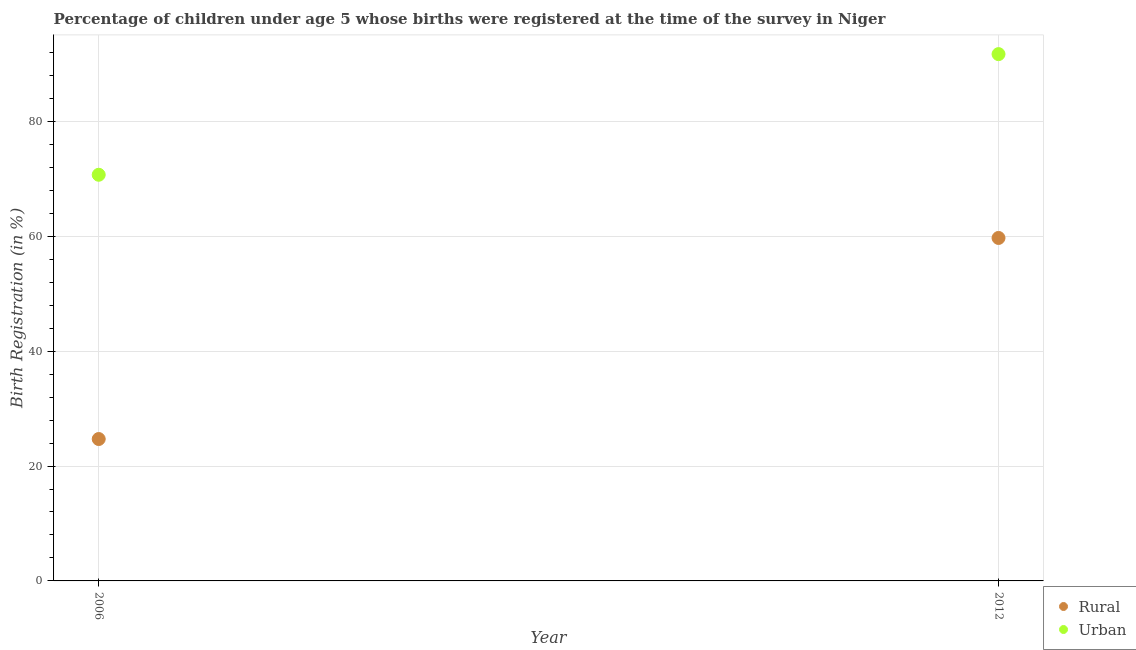How many different coloured dotlines are there?
Your response must be concise. 2. Is the number of dotlines equal to the number of legend labels?
Ensure brevity in your answer.  Yes. What is the urban birth registration in 2006?
Provide a short and direct response. 70.7. Across all years, what is the maximum rural birth registration?
Provide a succinct answer. 59.7. Across all years, what is the minimum urban birth registration?
Ensure brevity in your answer.  70.7. In which year was the urban birth registration minimum?
Ensure brevity in your answer.  2006. What is the total rural birth registration in the graph?
Offer a terse response. 84.4. What is the difference between the rural birth registration in 2006 and that in 2012?
Your answer should be very brief. -35. What is the difference between the rural birth registration in 2006 and the urban birth registration in 2012?
Your answer should be very brief. -67. What is the average urban birth registration per year?
Provide a short and direct response. 81.2. In the year 2012, what is the difference between the rural birth registration and urban birth registration?
Give a very brief answer. -32. What is the ratio of the urban birth registration in 2006 to that in 2012?
Offer a very short reply. 0.77. In how many years, is the rural birth registration greater than the average rural birth registration taken over all years?
Your answer should be compact. 1. Does the urban birth registration monotonically increase over the years?
Keep it short and to the point. Yes. Is the urban birth registration strictly less than the rural birth registration over the years?
Keep it short and to the point. No. How many dotlines are there?
Give a very brief answer. 2. How many years are there in the graph?
Ensure brevity in your answer.  2. What is the difference between two consecutive major ticks on the Y-axis?
Provide a short and direct response. 20. Where does the legend appear in the graph?
Give a very brief answer. Bottom right. What is the title of the graph?
Your answer should be compact. Percentage of children under age 5 whose births were registered at the time of the survey in Niger. What is the label or title of the X-axis?
Your answer should be very brief. Year. What is the label or title of the Y-axis?
Provide a succinct answer. Birth Registration (in %). What is the Birth Registration (in %) of Rural in 2006?
Make the answer very short. 24.7. What is the Birth Registration (in %) in Urban in 2006?
Offer a very short reply. 70.7. What is the Birth Registration (in %) in Rural in 2012?
Your answer should be very brief. 59.7. What is the Birth Registration (in %) in Urban in 2012?
Give a very brief answer. 91.7. Across all years, what is the maximum Birth Registration (in %) of Rural?
Keep it short and to the point. 59.7. Across all years, what is the maximum Birth Registration (in %) in Urban?
Provide a short and direct response. 91.7. Across all years, what is the minimum Birth Registration (in %) in Rural?
Keep it short and to the point. 24.7. Across all years, what is the minimum Birth Registration (in %) in Urban?
Offer a very short reply. 70.7. What is the total Birth Registration (in %) in Rural in the graph?
Give a very brief answer. 84.4. What is the total Birth Registration (in %) in Urban in the graph?
Provide a succinct answer. 162.4. What is the difference between the Birth Registration (in %) of Rural in 2006 and that in 2012?
Keep it short and to the point. -35. What is the difference between the Birth Registration (in %) in Rural in 2006 and the Birth Registration (in %) in Urban in 2012?
Provide a short and direct response. -67. What is the average Birth Registration (in %) of Rural per year?
Provide a succinct answer. 42.2. What is the average Birth Registration (in %) in Urban per year?
Offer a terse response. 81.2. In the year 2006, what is the difference between the Birth Registration (in %) in Rural and Birth Registration (in %) in Urban?
Offer a terse response. -46. In the year 2012, what is the difference between the Birth Registration (in %) in Rural and Birth Registration (in %) in Urban?
Ensure brevity in your answer.  -32. What is the ratio of the Birth Registration (in %) in Rural in 2006 to that in 2012?
Provide a succinct answer. 0.41. What is the ratio of the Birth Registration (in %) in Urban in 2006 to that in 2012?
Your answer should be very brief. 0.77. What is the difference between the highest and the second highest Birth Registration (in %) of Urban?
Your answer should be compact. 21. What is the difference between the highest and the lowest Birth Registration (in %) in Rural?
Offer a very short reply. 35. What is the difference between the highest and the lowest Birth Registration (in %) of Urban?
Your answer should be compact. 21. 